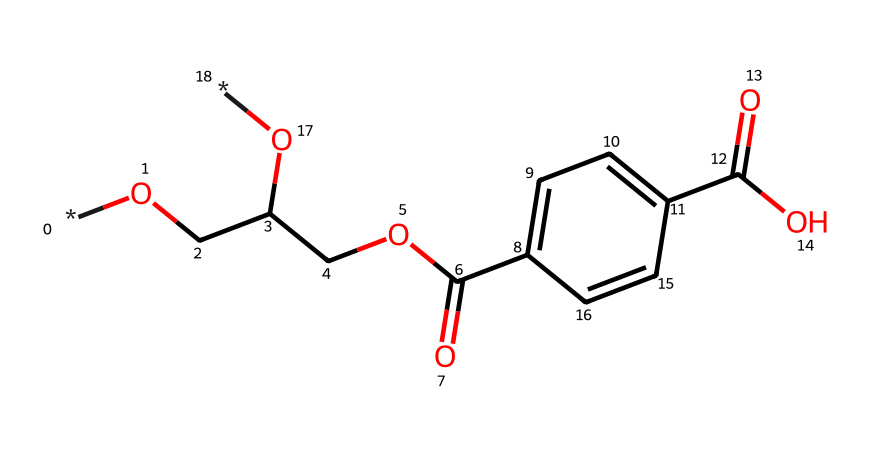What is the main functional group present in the structure? The structure reveals a carboxylic acid functional group (-COOH) due to the presence of a carbon atom double-bonded to an oxygen atom and single-bonded to a hydroxyl group (-OH). This indicates that there is a carboxylic acid present in the chemical.
Answer: carboxylic acid How many carbon atoms are in the chemical structure? By analyzing the SMILES representation, there are a total of 10 carbon atoms that can be counted from the structure, including those in the aromatic ring and the main chain.
Answer: 10 What type of polymer is represented by this chemical structure? The presence of repeating ester units and the overall structure indicate that it is a polyester, which is a type of polymer formed through condensation reactions of diols and dicarboxylic acids.
Answer: polyester Are there any aromatic rings in the structure? The presence of "c" in the SMILES indicates that there are aromatic carbon atoms, confirming that there is an aromatic ring within the structure.
Answer: yes What is the degree of polymerization of PET typically used in applications like water bottles? Polyethylene terephthalate (PET) commonly used in disposable water bottles typically has a degree of polymerization ranging from 100 to 200, which refers to the number of repeating units in the polymer chain.
Answer: 100 to 200 Which property allows PET to be used for disposable water bottles? The high tensile strength and excellent barrier properties against moisture and gases make PET suitable for use in disposable water bottles, allowing it to maintain the integrity of the contained liquids.
Answer: high tensile strength 